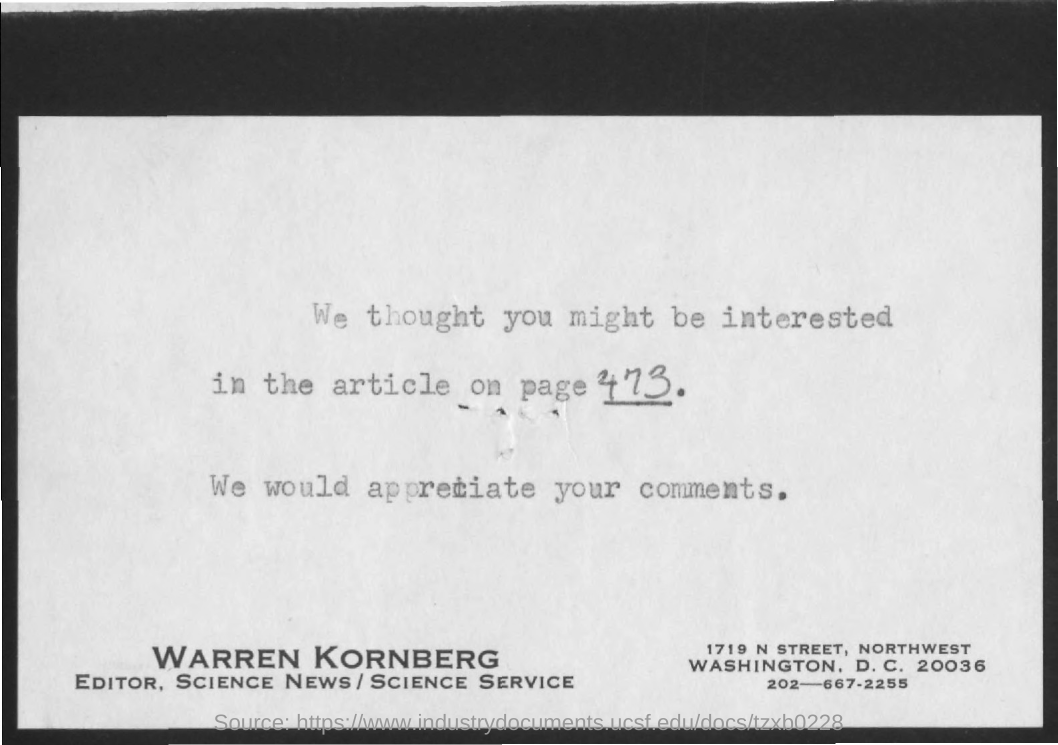Draw attention to some important aspects in this diagram. The page number for the article is 473. The editor named Warren Kornberg was mentioned. 